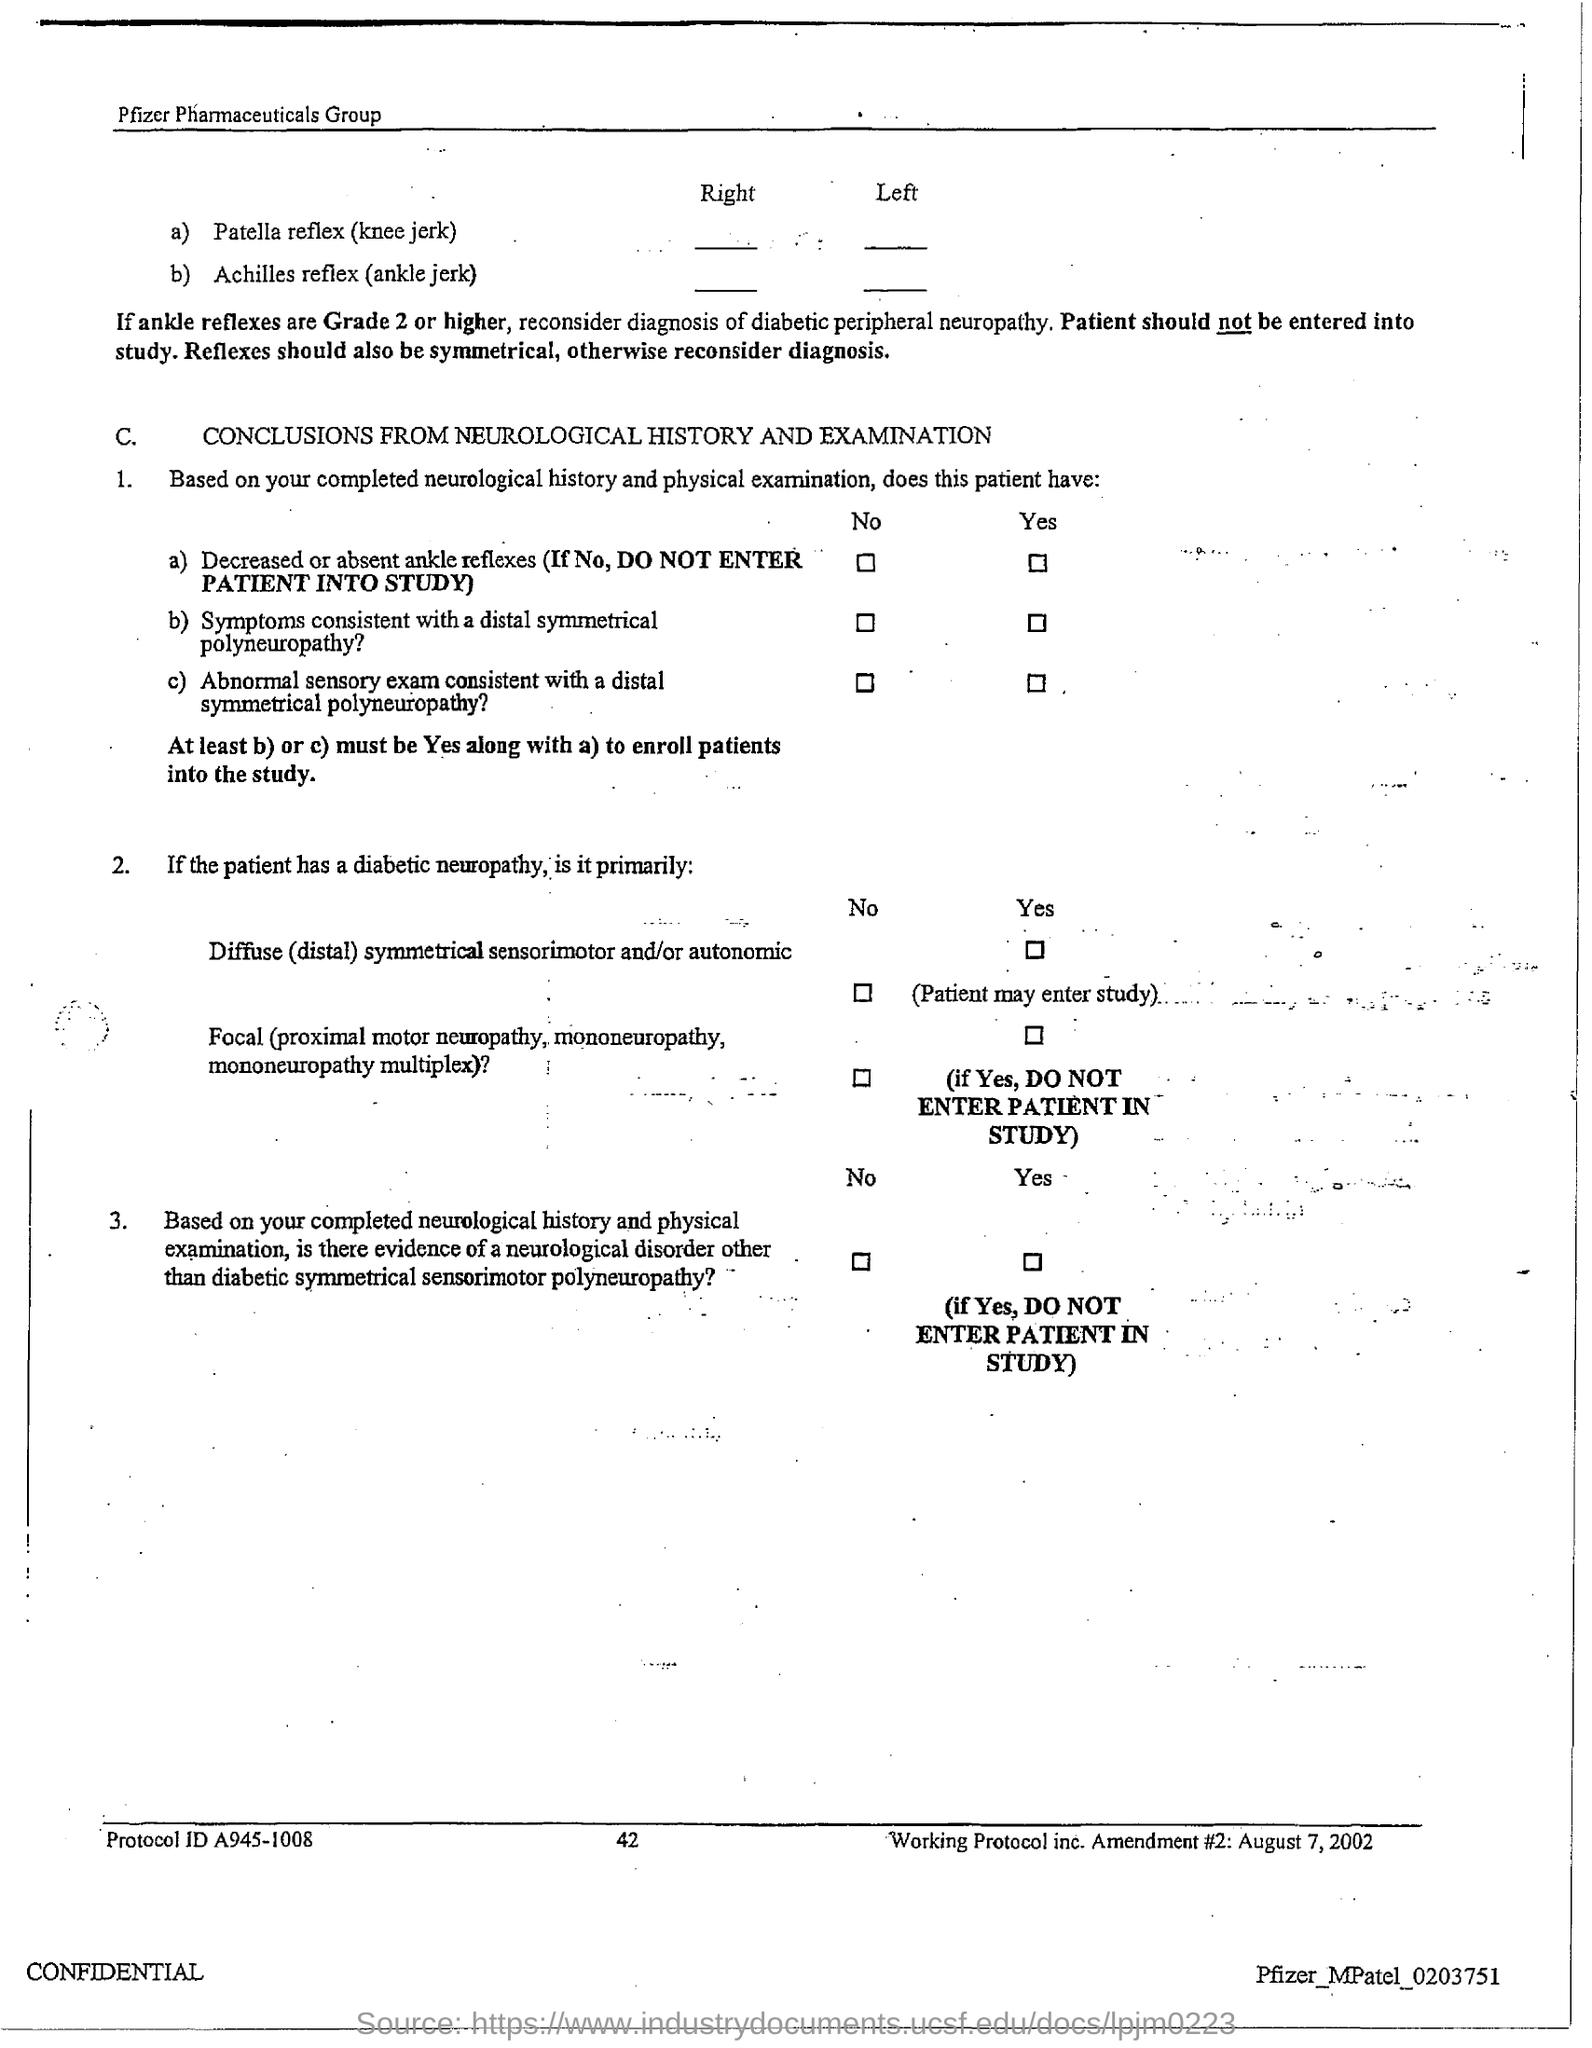Highlight a few significant elements in this photo. The page number mentioned in this document is 42. The Protocol ID mentioned in the document is A945-1008. 